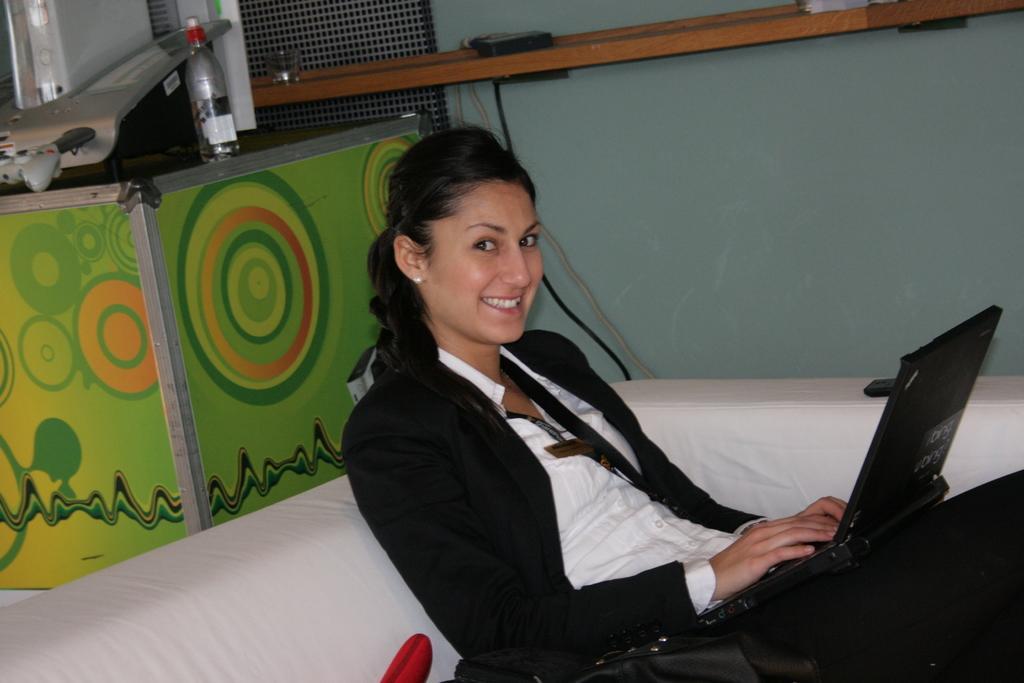Please provide a concise description of this image. In this image I can see the person sitting and holding the laptop. The person is wearing the black and white color dress. In the background I can see the the ash color object on the surface. To the side I can see the brown color shelf. On the shelf there is a glass and many objects. I can also see the wall in the back. 